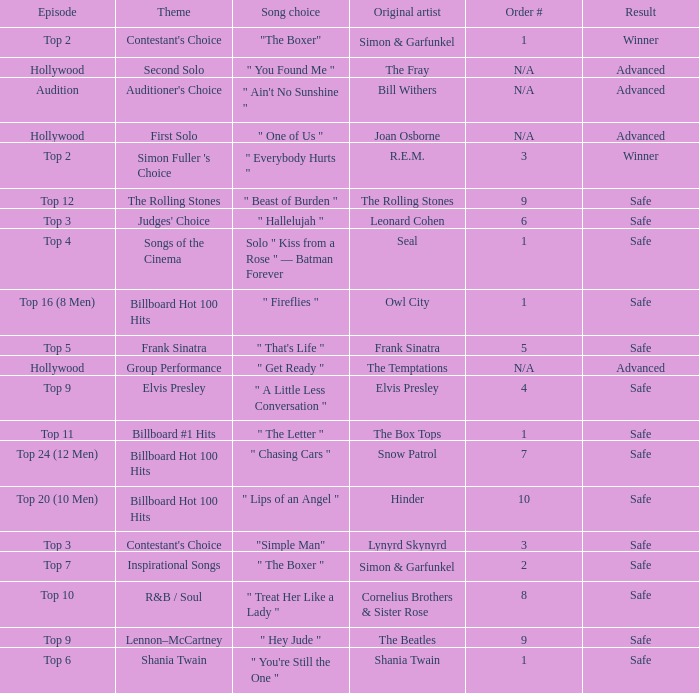The theme auditioner's preference includes what song selection? " Ain't No Sunshine ". 